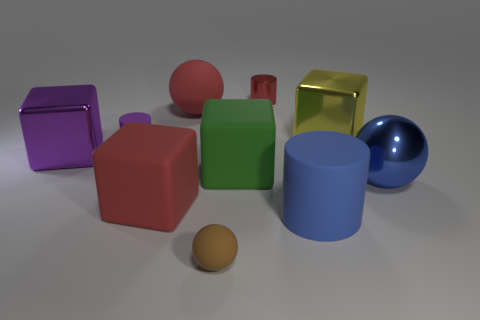Are there any other things that have the same material as the large blue ball?
Offer a terse response. Yes. There is a large rubber object that is to the right of the small metal cylinder; does it have the same shape as the big green thing?
Keep it short and to the point. No. What color is the metal cube that is on the right side of the small purple rubber cylinder?
Give a very brief answer. Yellow. What shape is the green thing that is made of the same material as the small ball?
Ensure brevity in your answer.  Cube. Is there any other thing that has the same color as the metallic cylinder?
Offer a very short reply. Yes. Are there more large red spheres in front of the green rubber thing than small red shiny cylinders left of the tiny matte cylinder?
Make the answer very short. No. How many red shiny cylinders have the same size as the purple rubber thing?
Your answer should be very brief. 1. Are there fewer yellow metallic things that are left of the yellow metal cube than yellow objects that are in front of the large purple cube?
Offer a terse response. No. Are there any tiny brown matte things that have the same shape as the blue shiny object?
Your answer should be compact. Yes. Is the red shiny thing the same shape as the big purple shiny thing?
Provide a succinct answer. No. 